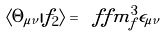Convert formula to latex. <formula><loc_0><loc_0><loc_500><loc_500>\langle \Theta _ { \mu \nu } | f _ { 2 } \rangle = \ f f m _ { f } ^ { 3 } \epsilon _ { \mu \nu }</formula> 